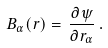<formula> <loc_0><loc_0><loc_500><loc_500>B _ { \alpha } ( { r } ) = \, \frac { \partial \psi } { \partial r _ { \alpha } } \, .</formula> 